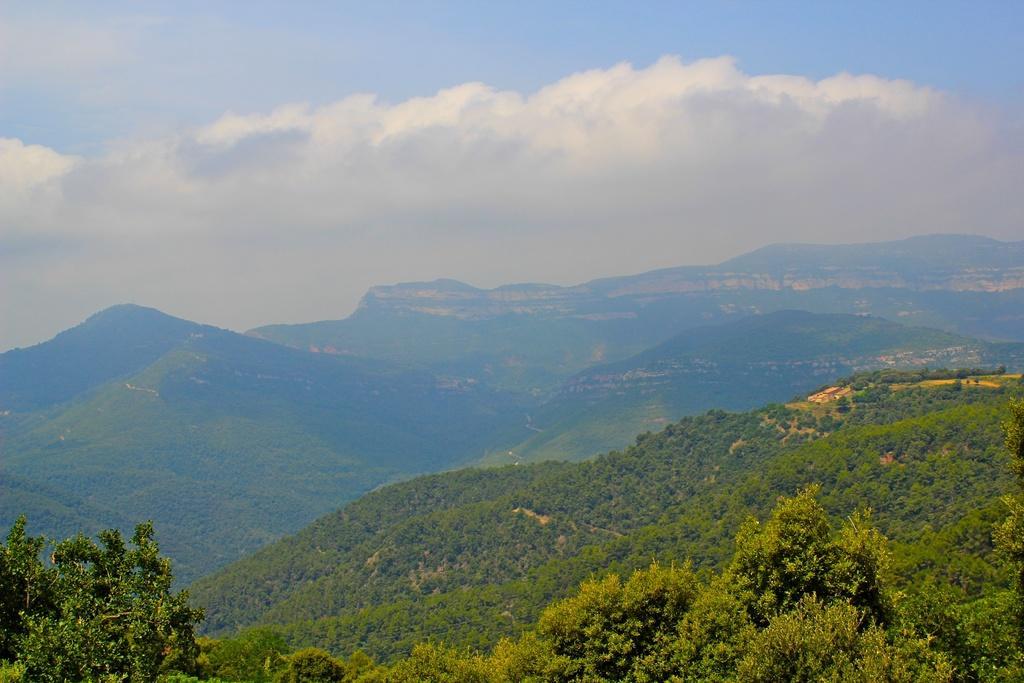How would you summarize this image in a sentence or two? There are plants and trees on a mountain. In the background, there are mountains and there are clouds in the blue sky. 